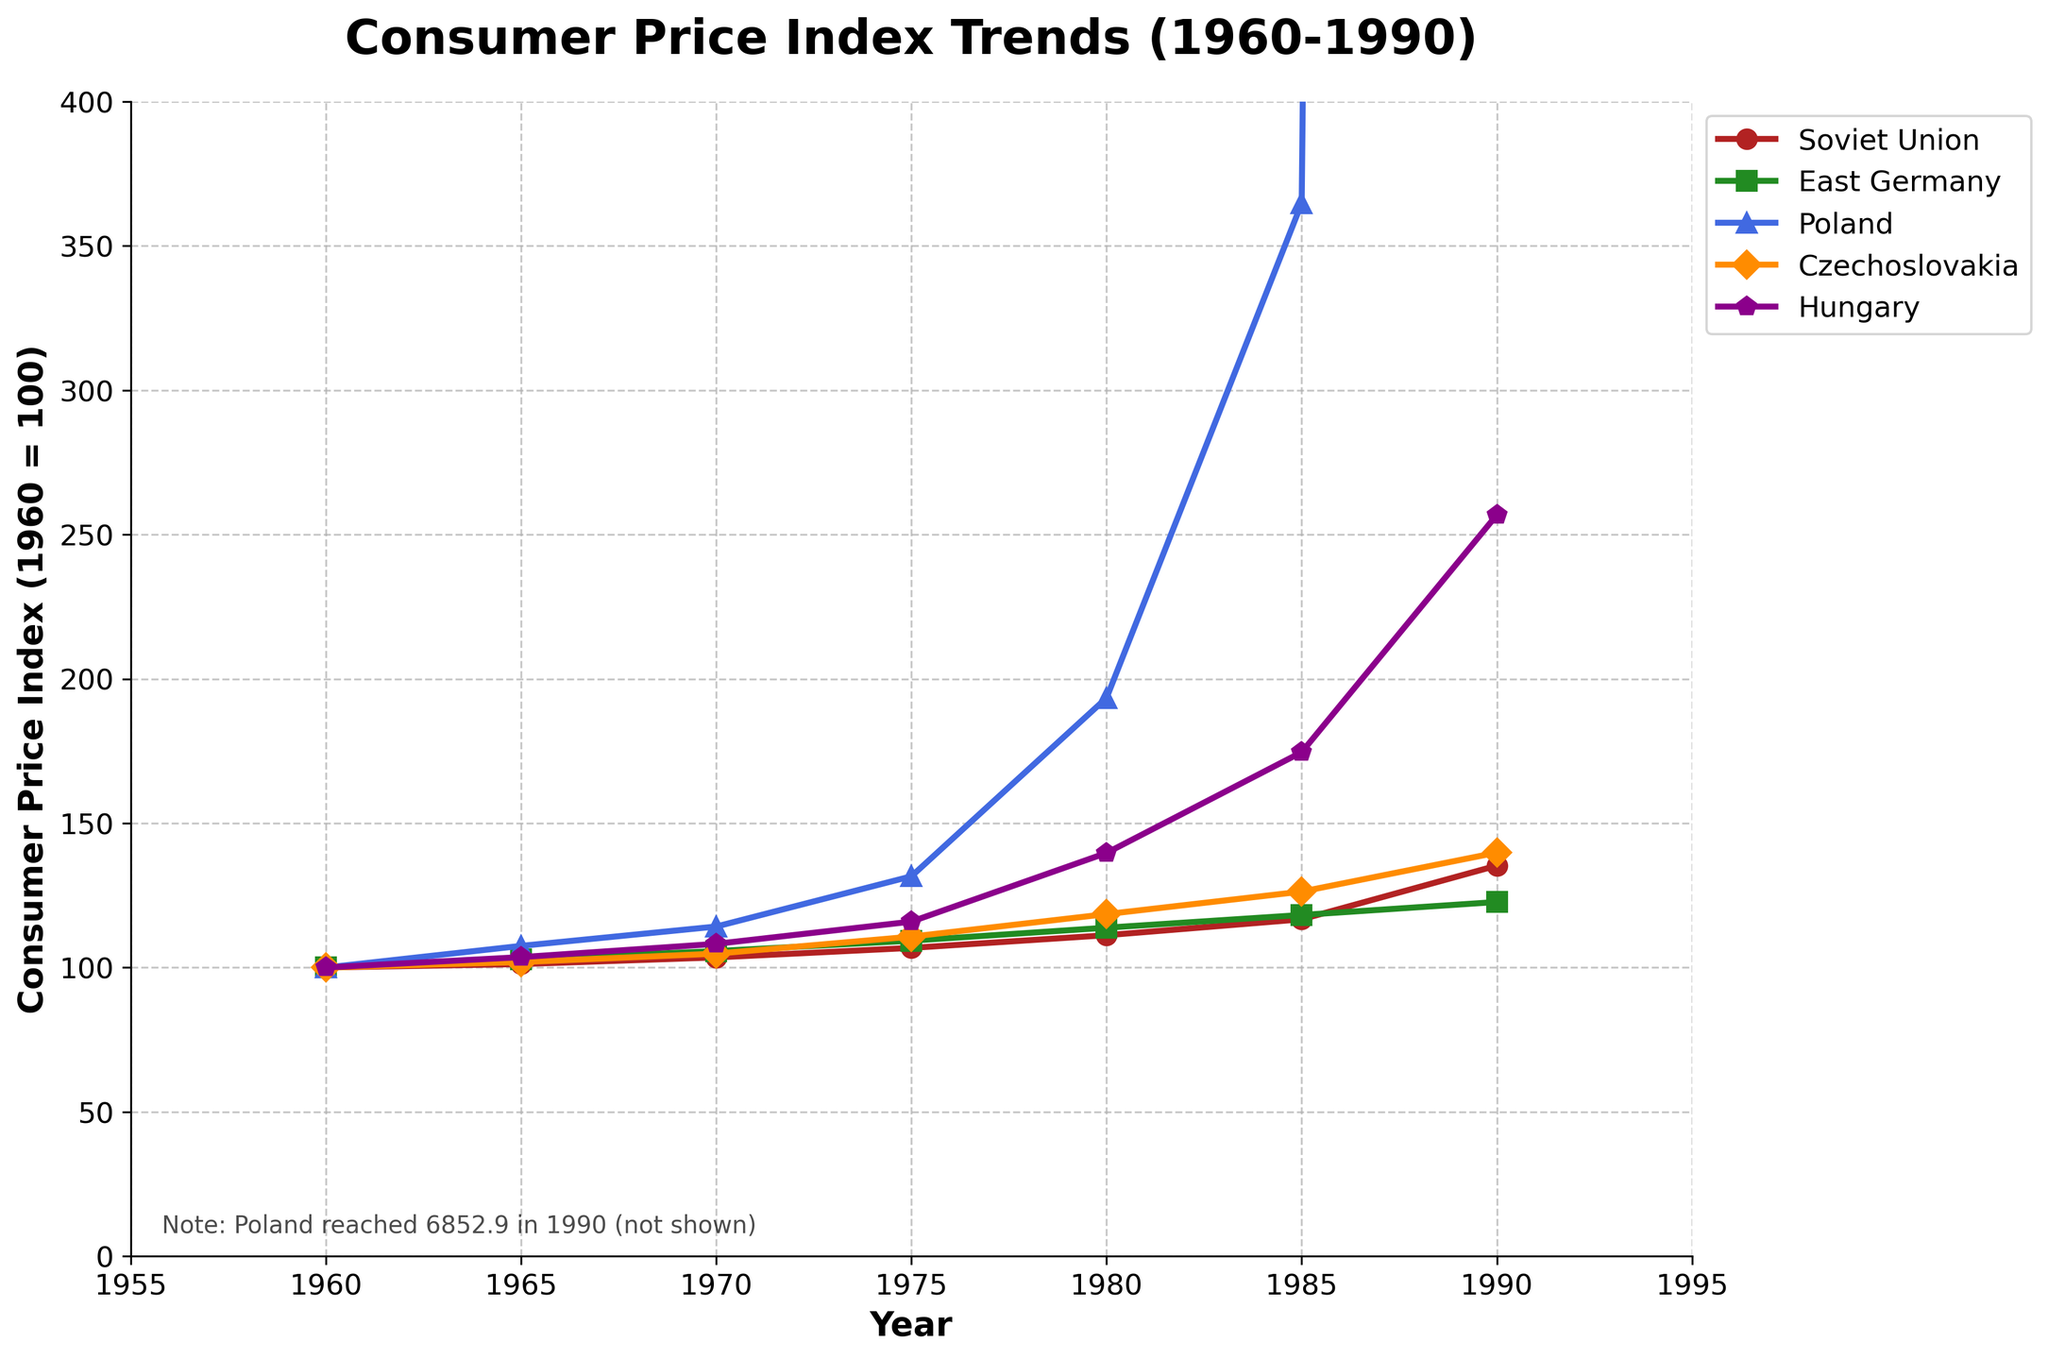What is the trend of the consumer price index in the Soviet Union from 1960 to 1990? The consumer price index for the Soviet Union shows a gradual increase from 1960 (100) to 1990 (135.3) over the 30-year period. This indicates a steady rise in consumer prices.
Answer: Gradual increase from 100 to 135.3 In 1990, which country had the highest consumer price index, and what was its value? In 1990, Poland had the highest consumer price index with a value of 6852.9, significantly higher than the other countries displayed in the chart.
Answer: Poland, 6852.9 How does the consumer price index of East Germany in 1975 compare to that of Czechoslovakia in the same year? In 1975, East Germany had a consumer price index of 109.3, whereas Czechoslovakia had a consumer price index of 110.7. Therefore, Czechoslovakia's index was slightly higher.
Answer: Czechoslovakia's index is higher What is the difference in the consumer price index between Hungary and the Soviet Union in 1985? In 1985, Hungary's consumer price index was 174.6 while the Soviet Union's was 116.7. The difference is calculated as 174.6 - 116.7 = 57.9.
Answer: 57.9 Describe the overall trend in Poland's consumer price index from 1960 to 1990. Poland's consumer price index showed a slight increase until around 1975, followed by a sharp rise between 1980 and 1990, skyrocketing to 6852.9 in 1990. This suggests a period of hyperinflation during the latter part of the 1980s.
Answer: Sharp increase, reaching 6852.9 in 1990 Which country showed the least variation in its consumer price index between 1960 and 1990? East Germany showed the least variation in its consumer price index, starting at 100 in 1960 and increasing to only 122.7 in 1990, indicating relatively stable prices compared to the other countries.
Answer: East Germany Rank the countries based on their consumer price indexes in 1980 from highest to lowest. In 1980, the consumer price indexes were as follows: Poland (193.4), Hungary (139.7), Czechoslovakia (118.5), East Germany (113.8), and Soviet Union (111.2).
Answer: Poland > Hungary > Czechoslovakia > East Germany > Soviet Union What color represents the consumer price index of Hungary in the chart? Hungary is represented by the color purple in the chart. This can be identified by the visually distinct color and matching it with the information in the legend.
Answer: Purple In which year did the Soviet Union's consumer price index show the largest increase compared to the previous measurement? The Soviet Union's consumer price index showed the largest increase between 1985 (116.7) and 1990 (135.3). The increase was 135.3 - 116.7 = 18.6.
Answer: Between 1985 and 1990 Compare the consumer price index trends of East Germany and Hungary during the 1970s. During the 1970s, East Germany's consumer price index rose steadily from 105.7 in 1970 to 113.8 in 1980. Meanwhile, Hungary's index also increased from 108.2 in 1970 to 139.7 in 1980, showing a steeper upward trend compared to East Germany.
Answer: Hungary had a steeper upward trend 